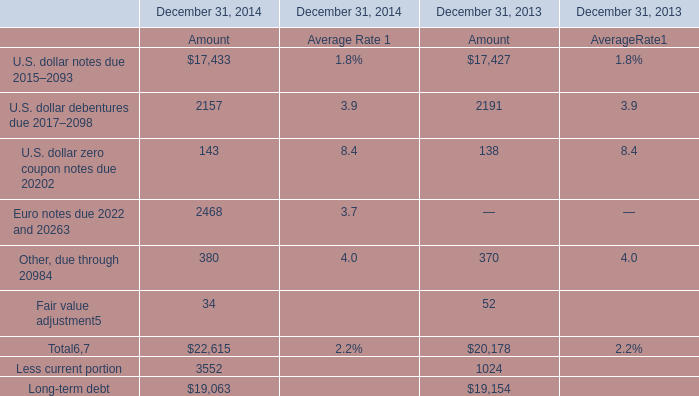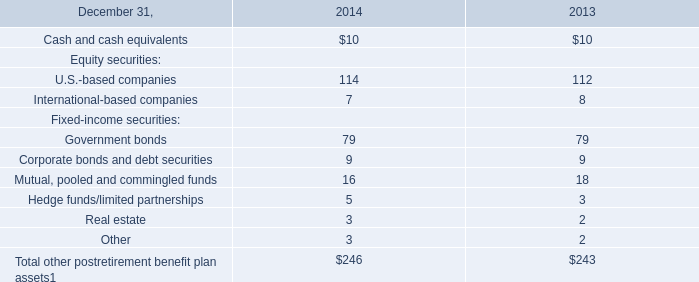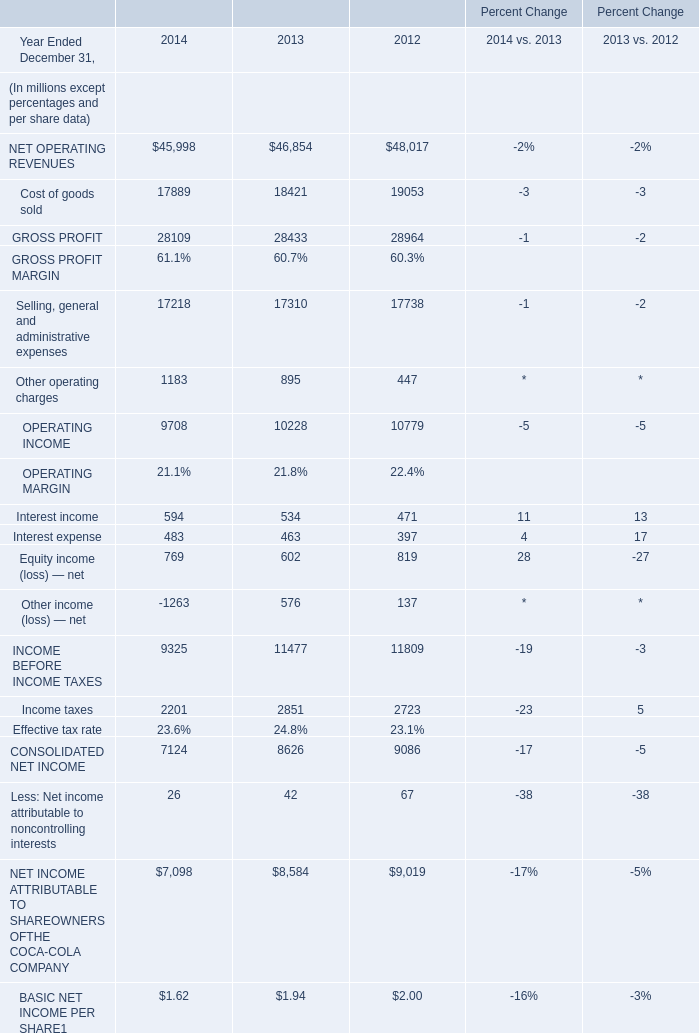What's the average of U.S. dollar debentures due 2017–2098 of December 31, 2014 Amount, and NET OPERATING REVENUES of Percent Change 2014 ? 
Computations: ((2157.0 + 45998.0) / 2)
Answer: 24077.5. 